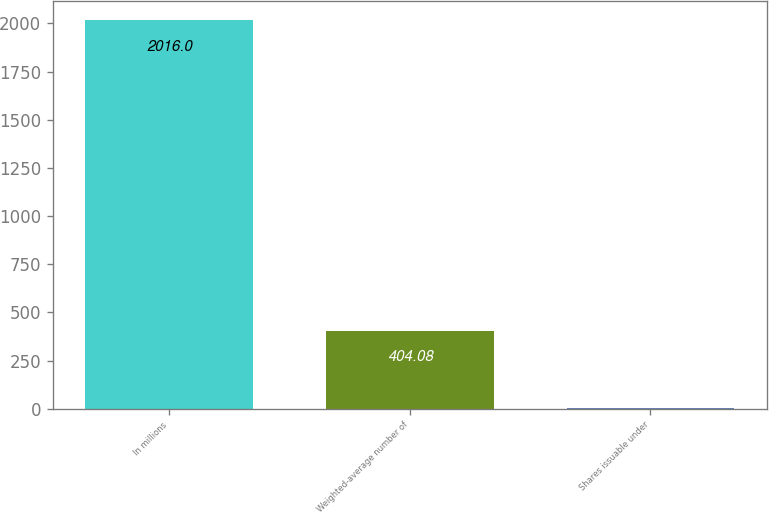Convert chart. <chart><loc_0><loc_0><loc_500><loc_500><bar_chart><fcel>In millions<fcel>Weighted-average number of<fcel>Shares issuable under<nl><fcel>2016<fcel>404.08<fcel>1.1<nl></chart> 